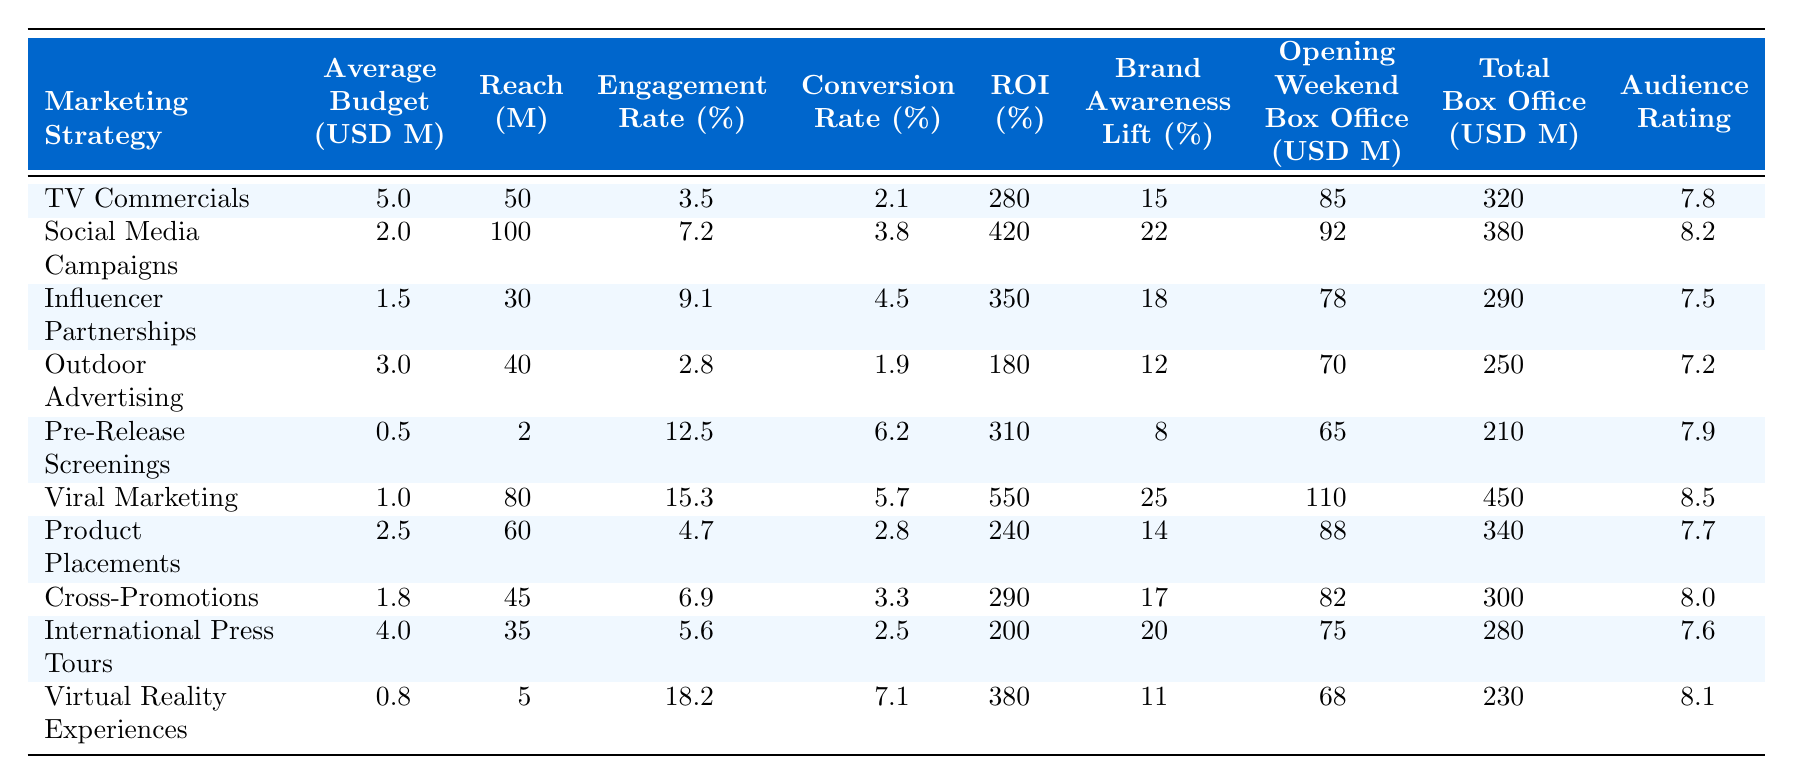What is the ROI for Viral Marketing? The ROI for Viral Marketing can be found directly in the table under the “ROI (%)” column, which shows 550% for this marketing strategy.
Answer: 550% Which marketing strategy had the highest engagement rate? By examining the "Engagement Rate (%)" column, the highest value is 18.2%, attributed to Virtual Reality Experiences.
Answer: Virtual Reality Experiences What is the difference in reach between Social Media Campaigns and Pre-Release Screenings? For Social Media Campaigns, the reach is 100 million, and for Pre-Release Screenings, it is 2 million. The difference is calculated as 100 - 2 = 98 million.
Answer: 98 million Is the average budget for Influencer Partnerships higher than that for Outdoor Advertising? The Average Budget for Influencer Partnerships is 1.5 million, and for Outdoor Advertising, it is 3.0 million. Since 1.5 is less than 3.0, the statement is false.
Answer: No What is the total box office revenue generated by TV Commercials and Product Placements combined? The total box office revenue for TV Commercials is 320 million, and for Product Placements, it is 340 million. Adding these gives 320 + 340 = 660 million.
Answer: 660 million Which marketing strategy has the lowest opening weekend box office revenue? By looking at the "Opening Weekend Box Office (USD Millions)" column, the lowest figure is 65 million for Pre-Release Screenings.
Answer: Pre-Release Screenings How does the average engagement rate compare for social media campaigns versus outdoor advertising? The engagement rate for Social Media Campaigns is 7.2%, while for Outdoor Advertising, it is 2.8%. Therefore, Social Media Campaigns have a higher engagement rate by 7.2 - 2.8 = 4.4%.
Answer: Higher by 4.4% What is the average conversion rate across all marketing strategies? The conversion rates are: 2.1, 3.8, 4.5, 1.9, 6.2, 5.7, 2.8, 3.3, 2.5, 7.1. Summing these totals gives 38.9 and dividing by 10 (the count of strategies) results in an average of 3.89%.
Answer: 3.89% Does any marketing strategy have a brand awareness lift greater than 20%? The Brand Awareness Lift (%) column shows values, and Social Media Campaigns have 22%, which is indeed greater than 20%, making the answer true.
Answer: Yes If we compare the audience ratings of Viral Marketing and Social Media Campaigns, which is higher? The Audience Rating for Viral Marketing is 8.5, while for Social Media Campaigns it is 8.2. Therefore, Viral Marketing has the higher rating by 8.5 - 8.2 = 0.3.
Answer: Viral Marketing 